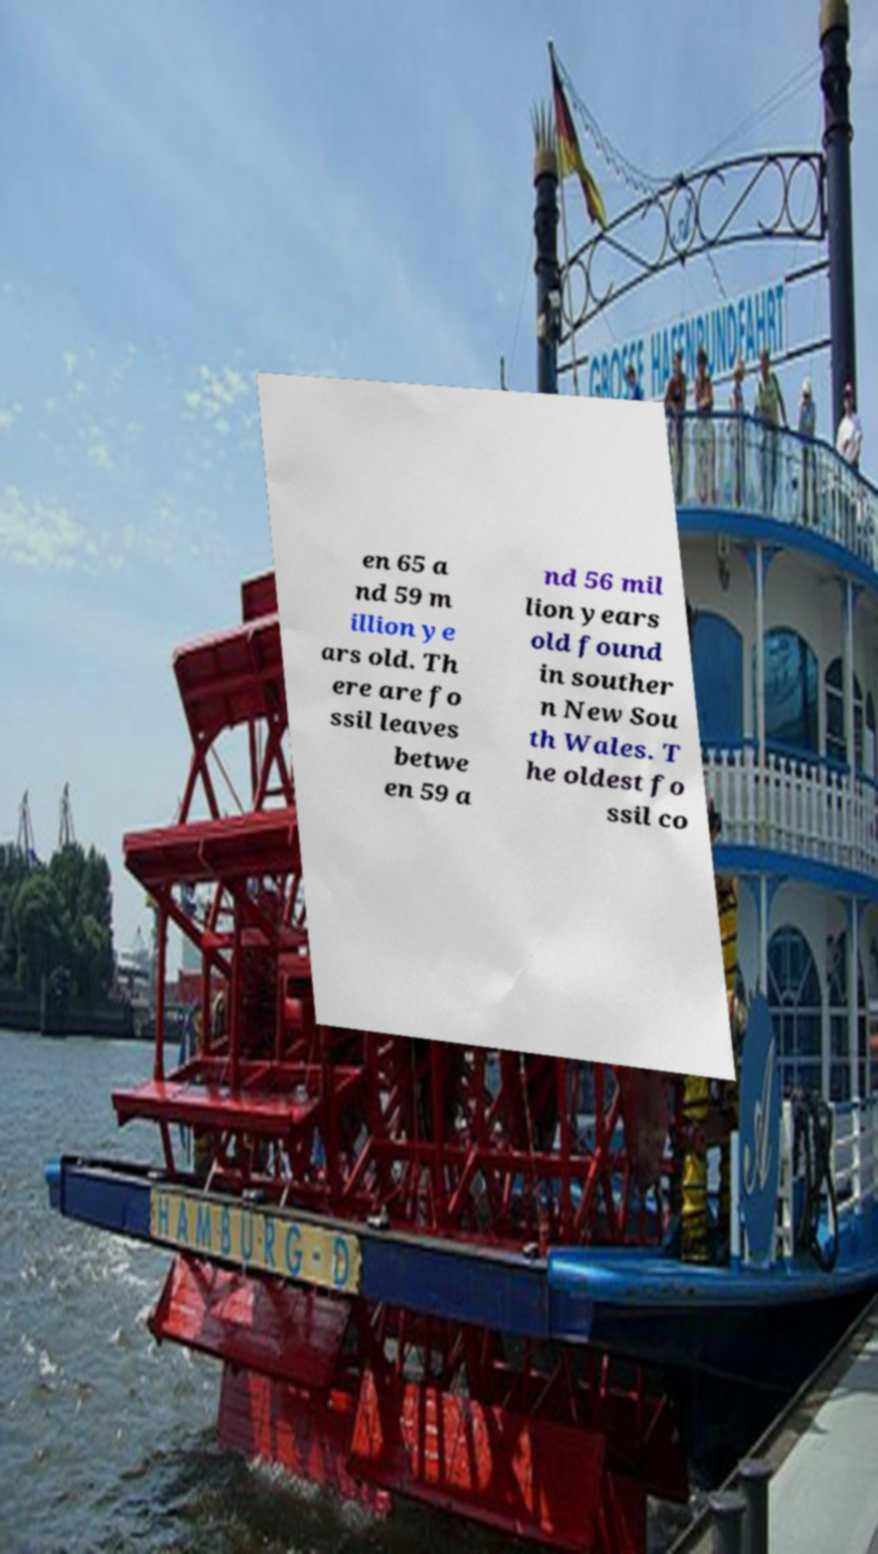Can you read and provide the text displayed in the image?This photo seems to have some interesting text. Can you extract and type it out for me? en 65 a nd 59 m illion ye ars old. Th ere are fo ssil leaves betwe en 59 a nd 56 mil lion years old found in souther n New Sou th Wales. T he oldest fo ssil co 